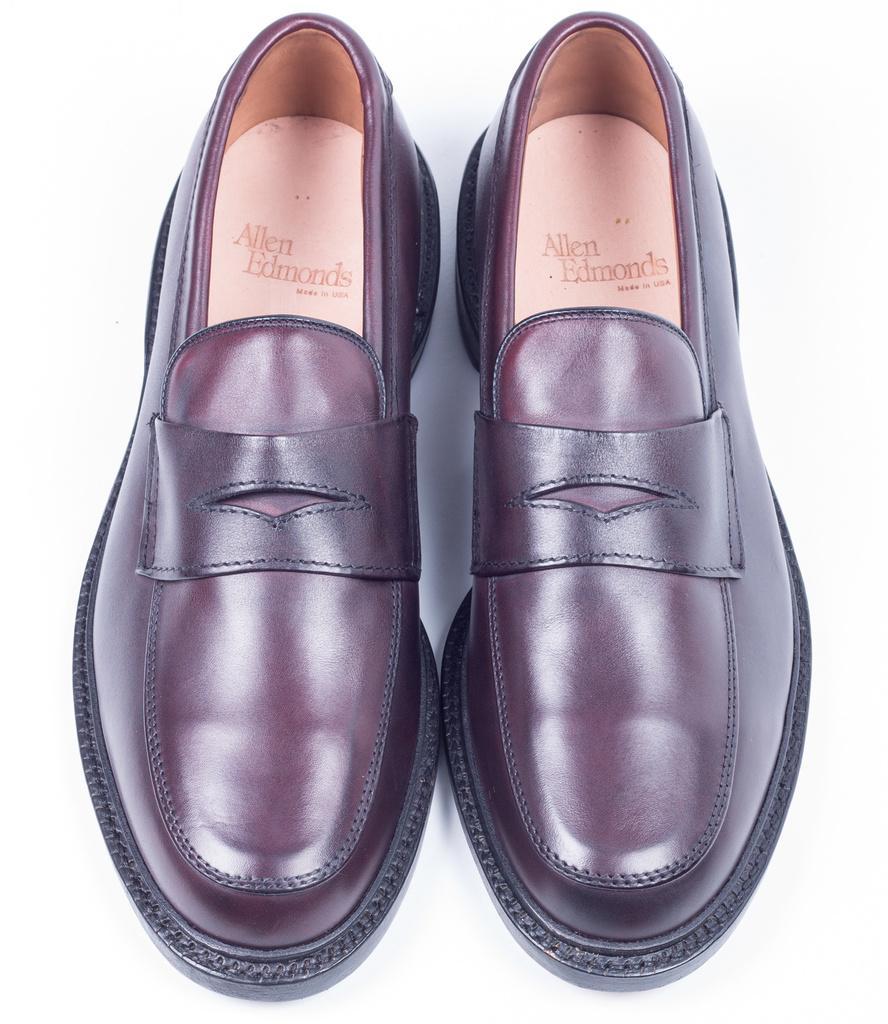Please provide a concise description of this image. In the picture we can see a pair of shoe which is black and brown in color and a name under it we can see Allen Edmond. 